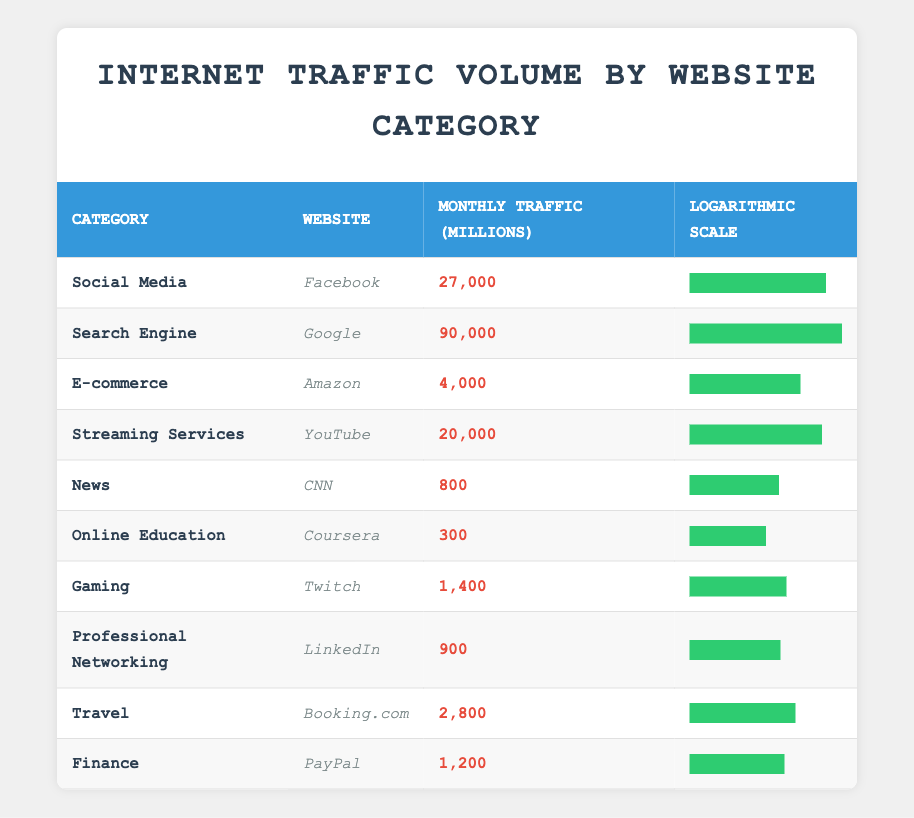What is the monthly traffic volume of Google? The table lists the specific monthly traffic volume for each website. For Google, under the category 'Search Engine,' the monthly traffic volume is 90,000 million.
Answer: 90,000 Which website has the highest monthly traffic volume? By examining the traffic volumes in the table, Google has the highest value at 90,000 million, which is greater than all other listed websites.
Answer: Google What is the difference in monthly traffic volume between Facebook and YouTube? The monthly traffic volume for Facebook is 27,000 million and for YouTube it is 20,000 million. The difference is calculated as 27,000 - 20,000 = 7,000 million.
Answer: 7,000 Is the monthly traffic volume of CNN greater than 1,000 million? The table shows that CNN has a traffic volume of 800 million. Since 800 million is less than 1,000 million, the answer is no.
Answer: No What is the average monthly traffic volume of E-commerce websites listed in the table? The only E-commerce website listed is Amazon with a traffic volume of 4,000 million. Since there is only one data point, the average is simply 4,000 million.
Answer: 4,000 How much monthly traffic volume does the category "Online Education" contribute compared to "Gaming"? The monthly traffic volumes are 300 million for Online Education and 1,400 million for Gaming. The difference is 1,400 - 300 = 1,100 million, meaning Gaming has significantly more traffic.
Answer: 1,100 Which category has the lowest website traffic volume, and what is that volume? By reviewing the table, the 'Online Education' category has the lowest traffic with Coursera at 300 million, which is less than all other categories listed.
Answer: Online Education, 300 What is the combined monthly traffic volume of Social Media and Streaming Services? For Social Media, the traffic volume of Facebook is 27,000 million, and for Streaming Services, YouTube is 20,000 million. The total is 27,000 + 20,000 = 47,000 million.
Answer: 47,000 How does the monthly traffic volume of LinkedIn compare to that of PayPal? LinkedIn has a traffic volume of 900 million while PayPal has 1,200 million. Therefore, PayPal has a higher traffic volume.
Answer: PayPal has a higher traffic volume 